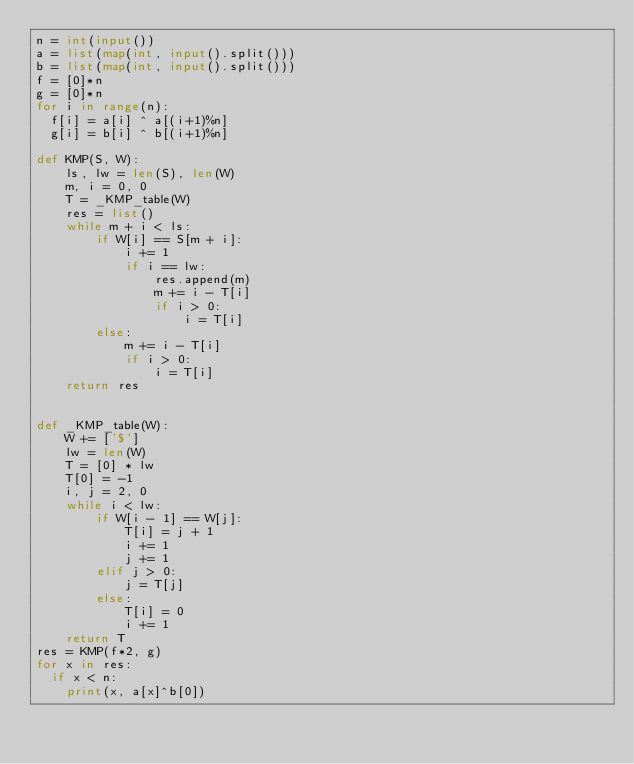<code> <loc_0><loc_0><loc_500><loc_500><_Python_>n = int(input())
a = list(map(int, input().split()))
b = list(map(int, input().split()))
f = [0]*n
g = [0]*n
for i in range(n):
  f[i] = a[i] ^ a[(i+1)%n]
  g[i] = b[i] ^ b[(i+1)%n]

def KMP(S, W):
    ls, lw = len(S), len(W)
    m, i = 0, 0
    T = _KMP_table(W)
    res = list()
    while m + i < ls:
        if W[i] == S[m + i]:
            i += 1
            if i == lw:
                res.append(m)
                m += i - T[i]
                if i > 0:
                    i = T[i]
        else:
            m += i - T[i]
            if i > 0:
                i = T[i]
    return res


def _KMP_table(W):
    W += ['$']
    lw = len(W)
    T = [0] * lw
    T[0] = -1
    i, j = 2, 0
    while i < lw:
        if W[i - 1] == W[j]:
            T[i] = j + 1
            i += 1
            j += 1
        elif j > 0:
            j = T[j]
        else:
            T[i] = 0
            i += 1
    return T
res = KMP(f*2, g)
for x in res:
  if x < n:
    print(x, a[x]^b[0])</code> 